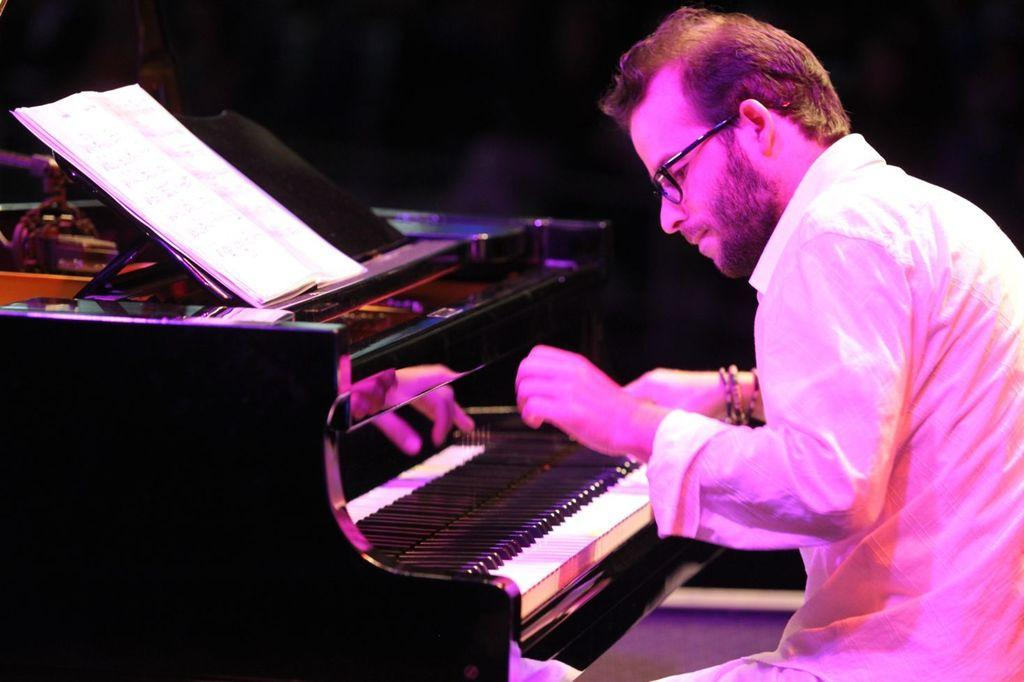What is the man in the image doing? The man is playing a piano keyboard in the image. What object is on the piano keyboard? There is a book on the piano keyboard. What type of slope can be seen in the background of the image? There is no slope visible in the image; it only features a man playing a piano keyboard with a book on it. 